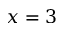<formula> <loc_0><loc_0><loc_500><loc_500>x = 3</formula> 